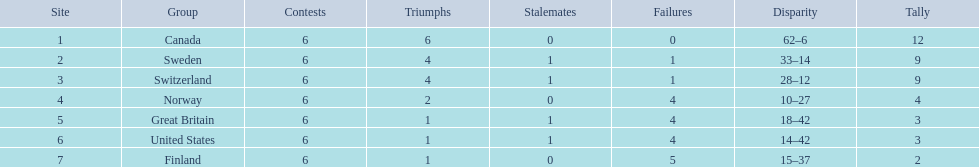Help me parse the entirety of this table. {'header': ['Site', 'Group', 'Contests', 'Triumphs', 'Stalemates', 'Failures', 'Disparity', 'Tally'], 'rows': [['1', 'Canada', '6', '6', '0', '0', '62–6', '12'], ['2', 'Sweden', '6', '4', '1', '1', '33–14', '9'], ['3', 'Switzerland', '6', '4', '1', '1', '28–12', '9'], ['4', 'Norway', '6', '2', '0', '4', '10–27', '4'], ['5', 'Great Britain', '6', '1', '1', '4', '18–42', '3'], ['6', 'United States', '6', '1', '1', '4', '14–42', '3'], ['7', 'Finland', '6', '1', '0', '5', '15–37', '2']]} What team placed after canada? Sweden. 